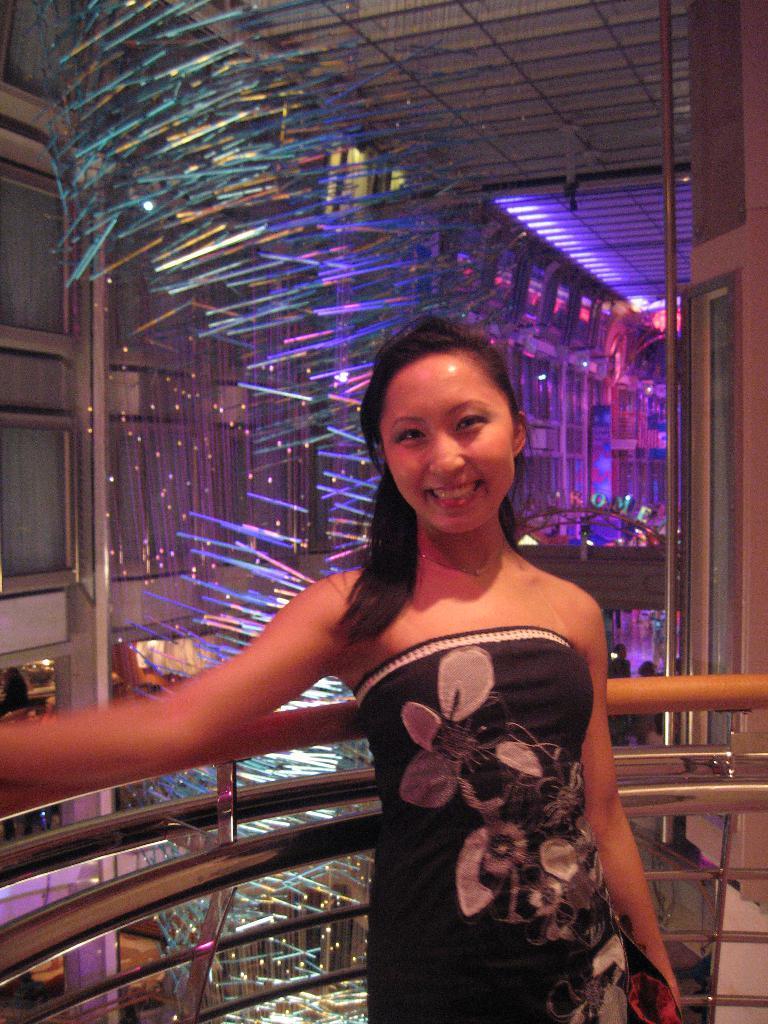How would you summarize this image in a sentence or two? In this image there is a woman standing towards the bottom of the image, she is holding an object, there is a metal object behind the woman, there is a pillar towards the bottom of the image, there is a wall towards the left of the image, there is a wall towards the right of the image, there are lights, there is a roof towards the top of the image. 